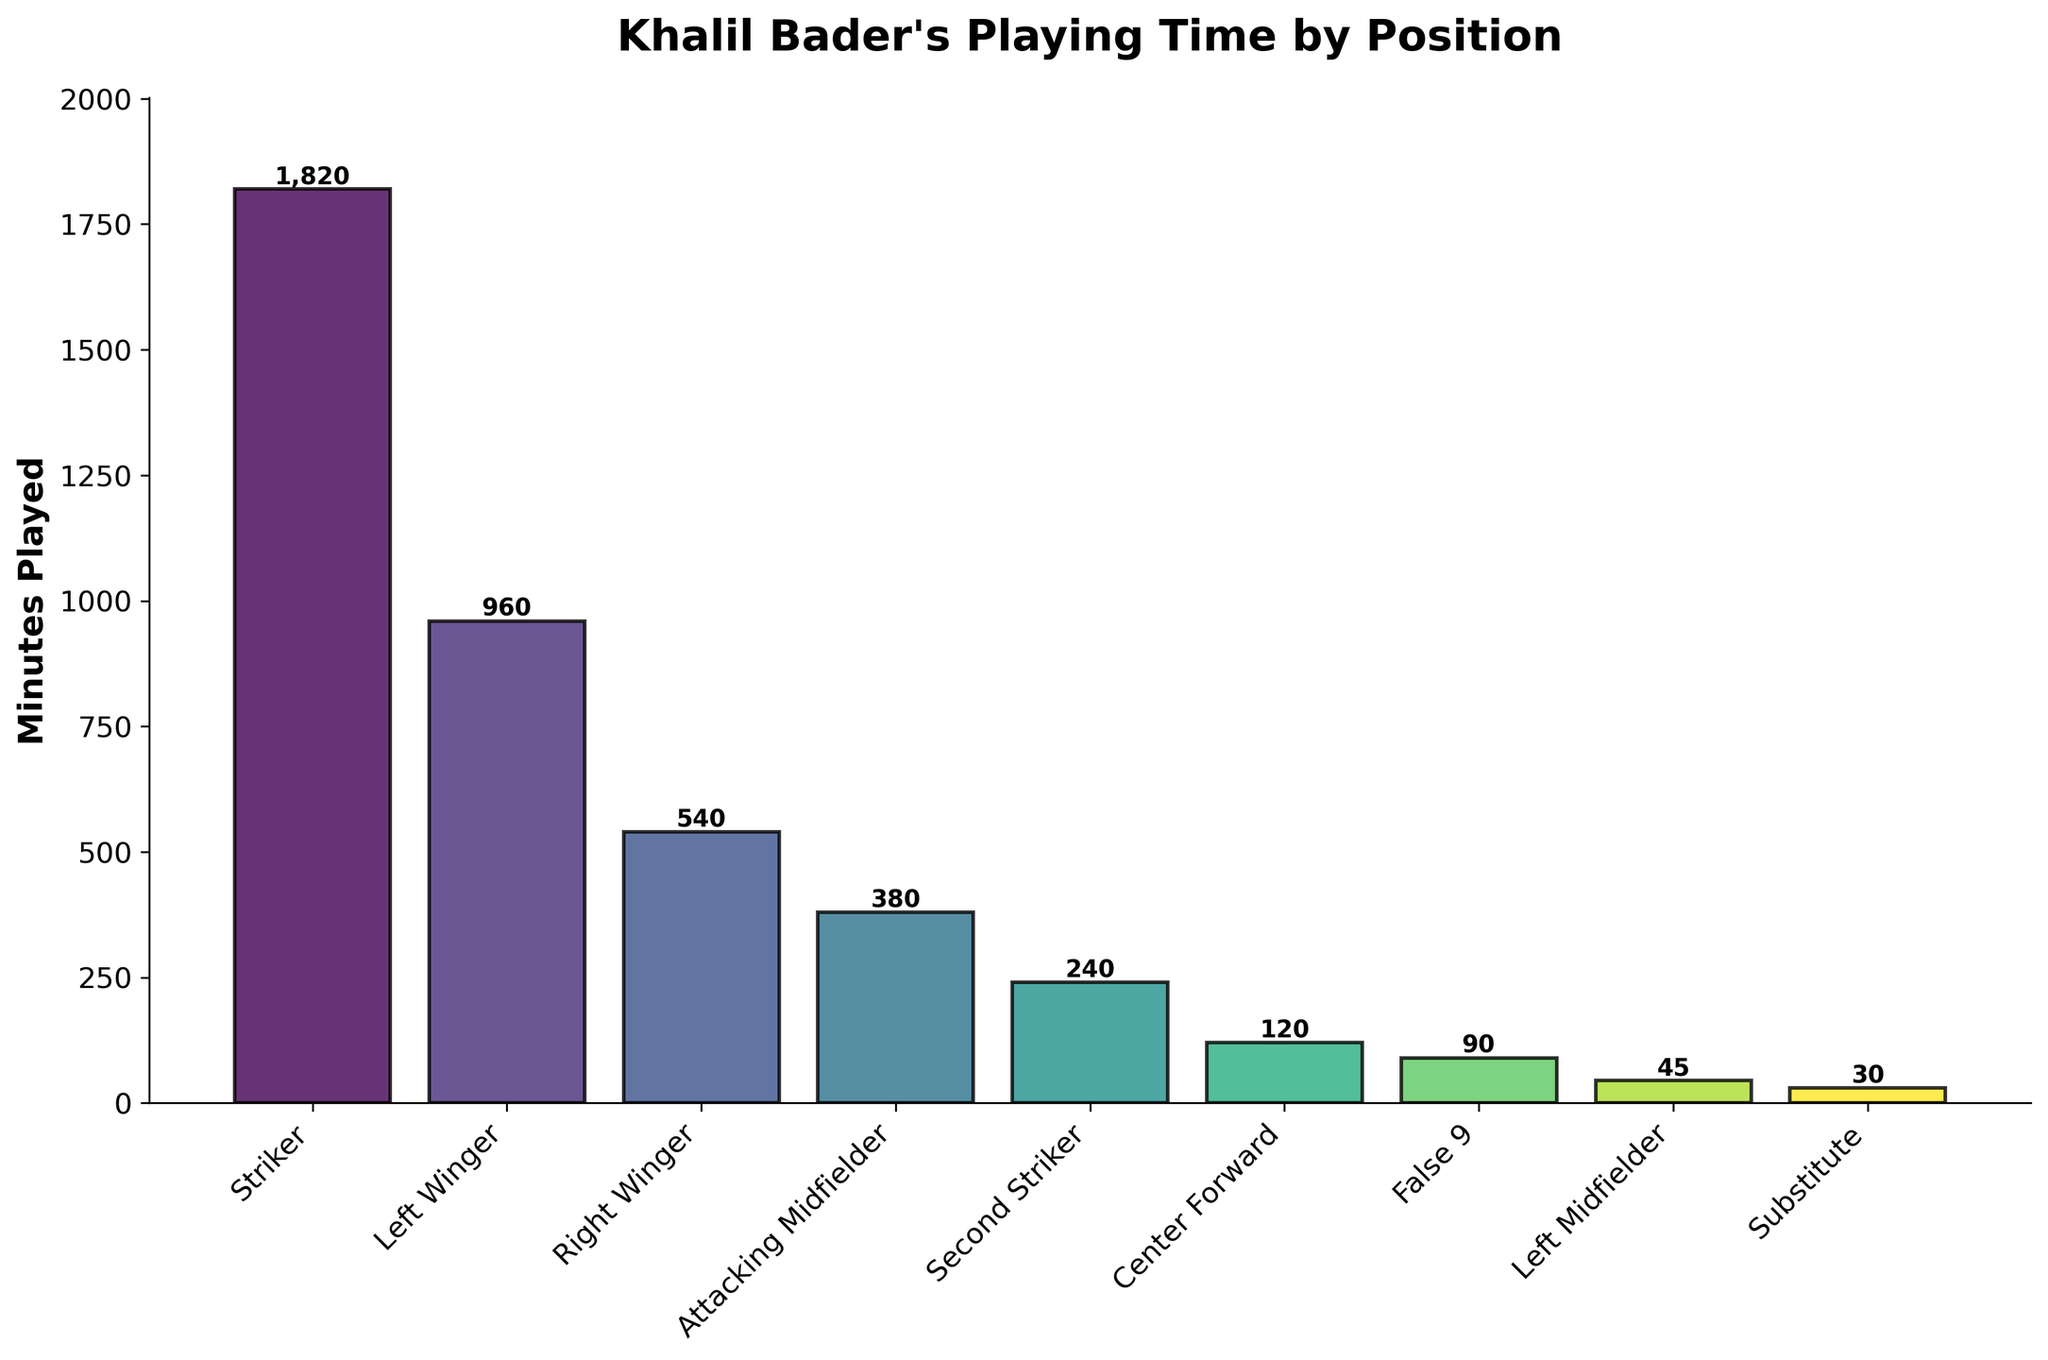How many minutes did Khalil Bader play as a Left Winger and Right Winger combined? To find the total minutes played as a Left Winger and Right Winger, add the minutes for both positions: 960 minutes + 540 minutes = 1500 minutes
Answer: 1500 Which position did Khalil Bader play the least amount of time, and how many minutes was it? By examining the heights of the bars, the smallest bar represents the Substitute position with 30 minutes played
Answer: Substitute, 30 Did Khalil Bader spend more time playing as a Striker or as an Attacking Midfielder? Compare the minutes played in each position: 1820 minutes as a Striker vs. 380 minutes as an Attacking Midfielder. Clearly, 1820 is greater than 380
Answer: Striker Is the total time spent playing Left Midfielder and Second Striker greater than the time spent as a Right Winger? Calculate the sum of the minutes for Left Midfielder (45) and Second Striker (240): 45 + 240 = 285. Compare this with 540 minutes as a Right Winger. Since 285 is less than 540, it's not greater
Answer: No What is the average time Khalil Bader spent playing each position listed in the chart? Sum all the minutes and divide by the number of positions: (1820 + 960 + 540 + 380 + 240 + 120 + 90 + 45 + 30) ÷ 9 = 4225 ÷ 9 ≈ 469.44 minutes
Answer: 469.44 Which position has the second-highest playing time, and how many minutes was it? Find the second-tallest bar after the Striker bar. The next highest bar represents the Left Winger position with 960 minutes played
Answer: Left Winger, 960 How many positions did Khalil Bader play for fewer than 100 minutes? Examine the chart and count the bars shorter than 100 minutes, which represent the Center Forward (120 minutes), False 9 (90 minutes), Left Midfielder (45 minutes), and Substitute (30 minutes). Only the False 9, Left Midfielder, and Substitute positions are below 100 minutes
Answer: 3 Are there more positions where Khalil Bader played more than 500 minutes or fewer than 500 minutes? Count the number of positions with bars taller than and shorter than 500 minutes: More than 500 minutes (Striker, Left Winger) = 2 positions; fewer than or equal to 500 minutes (Right Winger, Attacking Midfielder, Second Striker, Center Forward, False 9, Left Midfielder, Substitute) = 7 positions
Answer: Fewer than 500 minutes How many more minutes did Khalil Bader play as a Striker than as a Center Forward? Subtract the minutes played as a Center Forward from the minutes played as a Striker: 1820 - 120 = 1700 minutes
Answer: 1700 